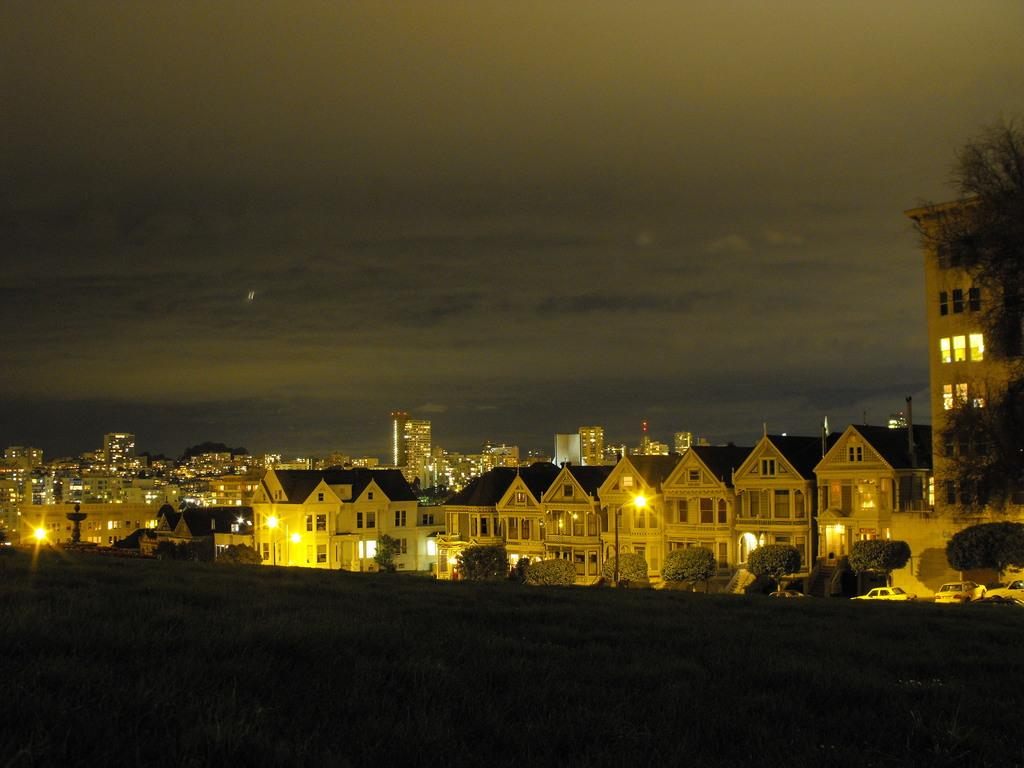What type of vegetation is present in the image? There is grass in the image. What other natural elements can be seen in the image? There are trees in the image. What man-made objects are visible in the image? There are vehicles, lights, poles, and buildings in the image. What can be seen in the background of the image? The sky is visible in the background of the image. Can you hear the argument between the trees in the image? There is no argument present in the image, as it is a visual representation and does not include sound. 